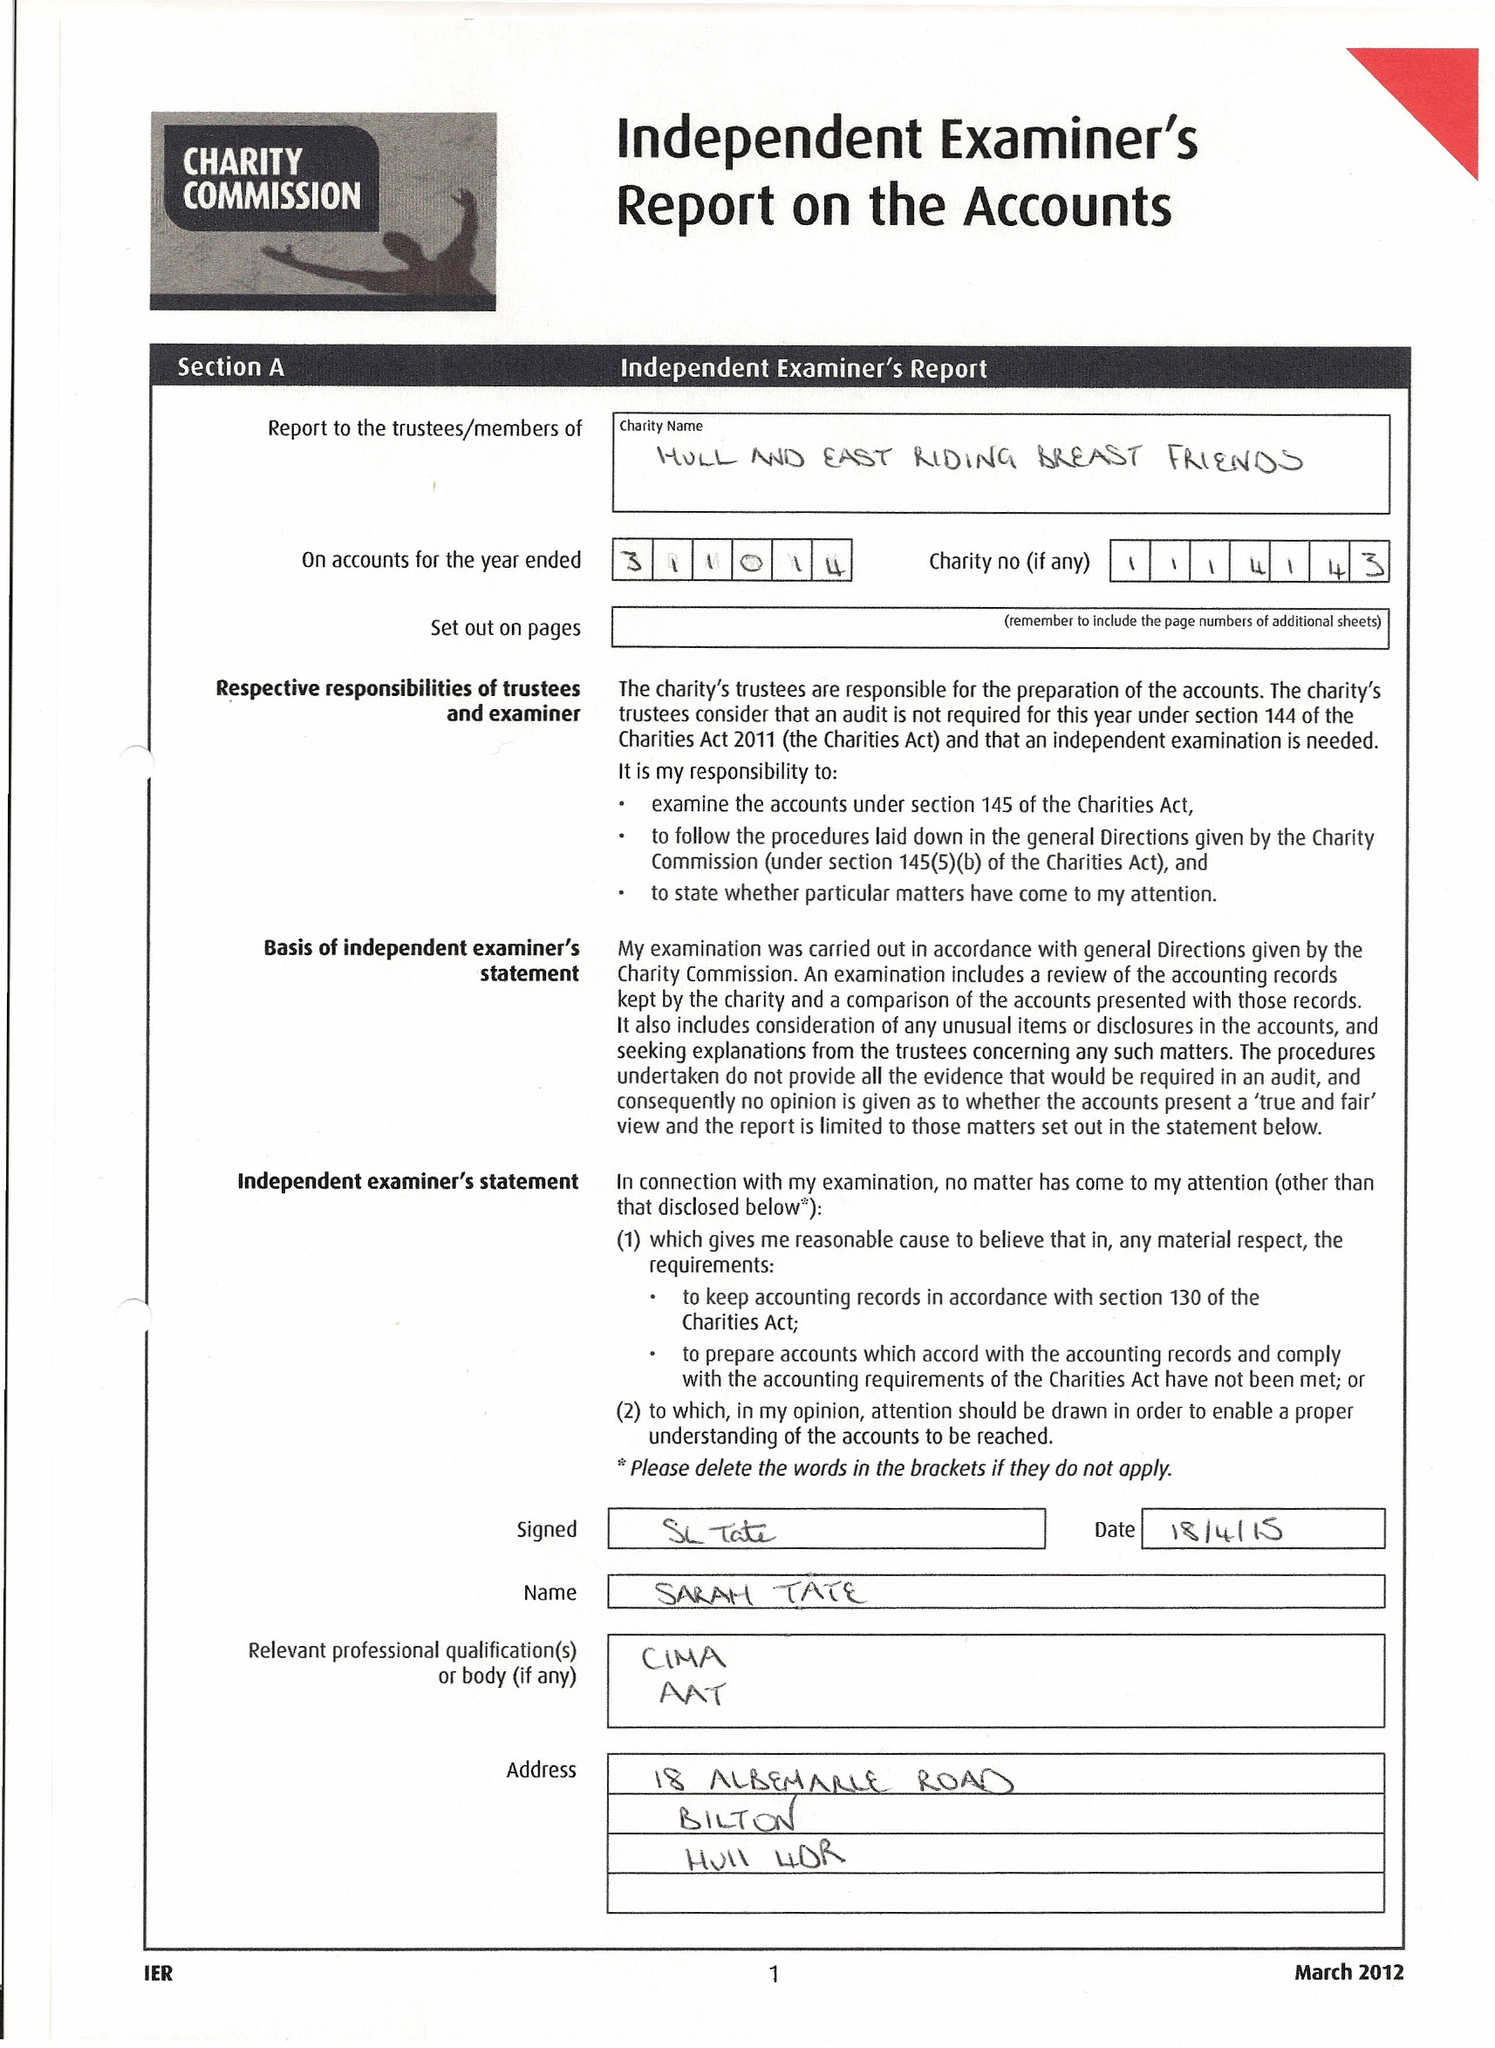What is the value for the spending_annually_in_british_pounds?
Answer the question using a single word or phrase. 43630.00 